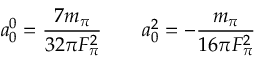<formula> <loc_0><loc_0><loc_500><loc_500>a _ { 0 } ^ { 0 } = { \frac { 7 m _ { \pi } } { 3 2 \pi F _ { \pi } ^ { 2 } } } \quad a _ { 0 } ^ { 2 } = - { \frac { m _ { \pi } } { 1 6 \pi F _ { \pi } ^ { 2 } } }</formula> 